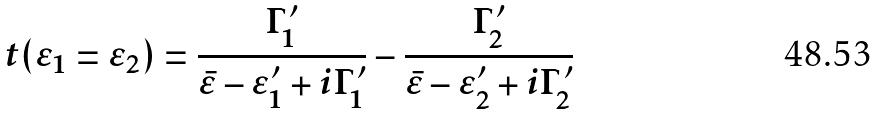Convert formula to latex. <formula><loc_0><loc_0><loc_500><loc_500>t ( \varepsilon _ { 1 } = \varepsilon _ { 2 } ) = \frac { \Gamma ^ { \prime } _ { 1 } } { \bar { \varepsilon } - \varepsilon ^ { \prime } _ { 1 } + i \Gamma ^ { \prime } _ { 1 } } - \frac { \Gamma ^ { \prime } _ { 2 } } { \bar { \varepsilon } - \varepsilon ^ { \prime } _ { 2 } + i \Gamma ^ { \prime } _ { 2 } }</formula> 